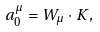<formula> <loc_0><loc_0><loc_500><loc_500>a _ { 0 } ^ { \mu } = { W } _ { \mu } \cdot { K } ,</formula> 